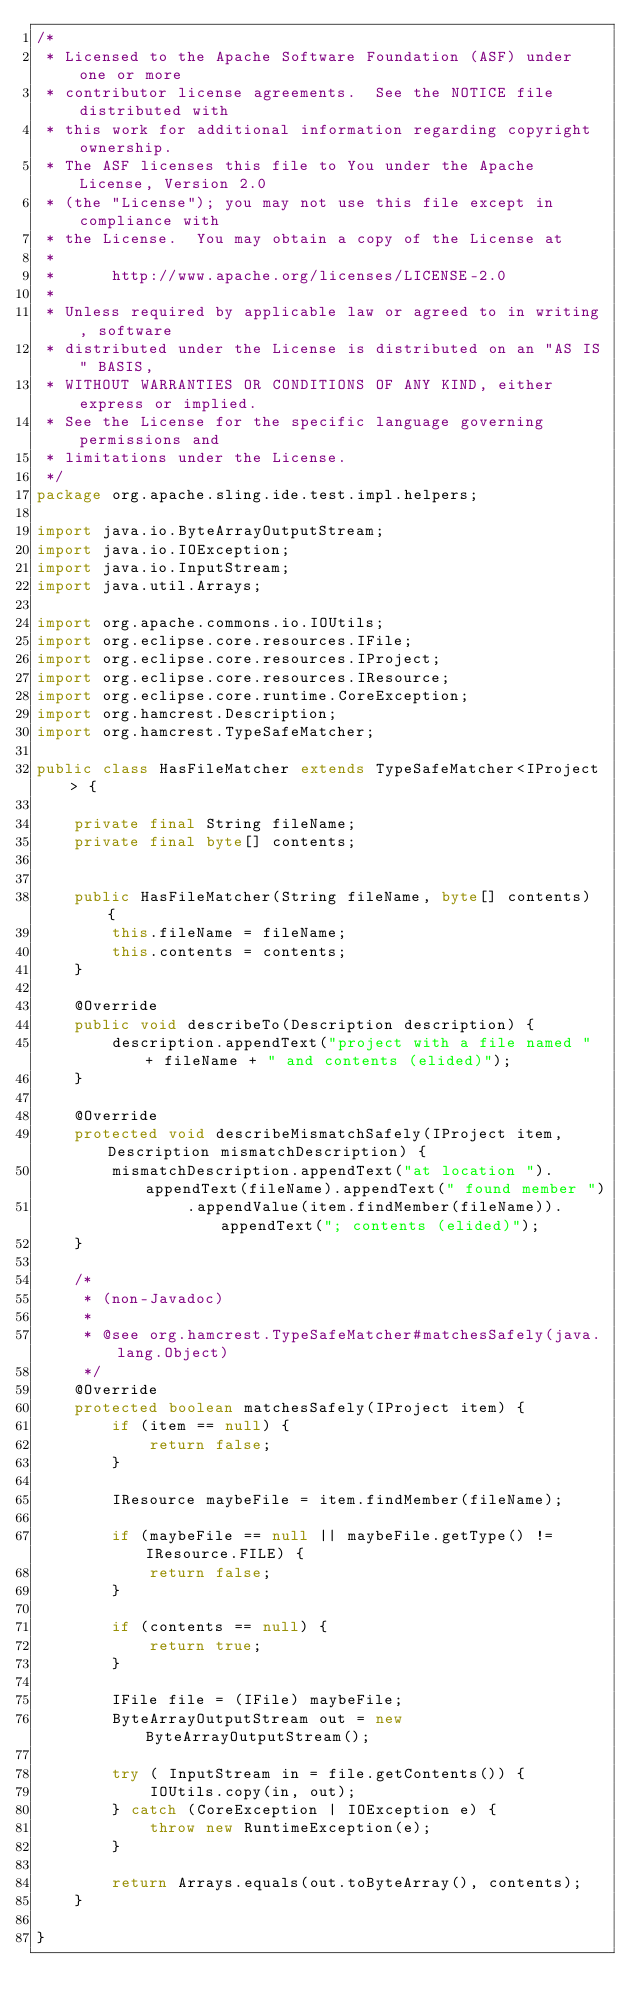<code> <loc_0><loc_0><loc_500><loc_500><_Java_>/*
 * Licensed to the Apache Software Foundation (ASF) under one or more
 * contributor license agreements.  See the NOTICE file distributed with
 * this work for additional information regarding copyright ownership.
 * The ASF licenses this file to You under the Apache License, Version 2.0
 * (the "License"); you may not use this file except in compliance with
 * the License.  You may obtain a copy of the License at
 *
 *      http://www.apache.org/licenses/LICENSE-2.0
 *
 * Unless required by applicable law or agreed to in writing, software
 * distributed under the License is distributed on an "AS IS" BASIS,
 * WITHOUT WARRANTIES OR CONDITIONS OF ANY KIND, either express or implied.
 * See the License for the specific language governing permissions and
 * limitations under the License.
 */
package org.apache.sling.ide.test.impl.helpers;

import java.io.ByteArrayOutputStream;
import java.io.IOException;
import java.io.InputStream;
import java.util.Arrays;

import org.apache.commons.io.IOUtils;
import org.eclipse.core.resources.IFile;
import org.eclipse.core.resources.IProject;
import org.eclipse.core.resources.IResource;
import org.eclipse.core.runtime.CoreException;
import org.hamcrest.Description;
import org.hamcrest.TypeSafeMatcher;

public class HasFileMatcher extends TypeSafeMatcher<IProject> {

    private final String fileName;
    private final byte[] contents;


    public HasFileMatcher(String fileName, byte[] contents) {
        this.fileName = fileName;
        this.contents = contents;
    }

    @Override
    public void describeTo(Description description) {
        description.appendText("project with a file named " + fileName + " and contents (elided)");
    }

    @Override
    protected void describeMismatchSafely(IProject item, Description mismatchDescription) {
        mismatchDescription.appendText("at location ").appendText(fileName).appendText(" found member ")
                .appendValue(item.findMember(fileName)).appendText("; contents (elided)");
    }

    /*
     * (non-Javadoc)
     * 
     * @see org.hamcrest.TypeSafeMatcher#matchesSafely(java.lang.Object)
     */
    @Override
    protected boolean matchesSafely(IProject item) {
        if (item == null) {
            return false;
        }

        IResource maybeFile = item.findMember(fileName);

        if (maybeFile == null || maybeFile.getType() != IResource.FILE) {
            return false;
        }

        if (contents == null) {
            return true;
        }

        IFile file = (IFile) maybeFile;
        ByteArrayOutputStream out = new ByteArrayOutputStream();

        try ( InputStream in = file.getContents()) {
            IOUtils.copy(in, out);
        } catch (CoreException | IOException e) {
            throw new RuntimeException(e);
        }

        return Arrays.equals(out.toByteArray(), contents);
    }

}</code> 